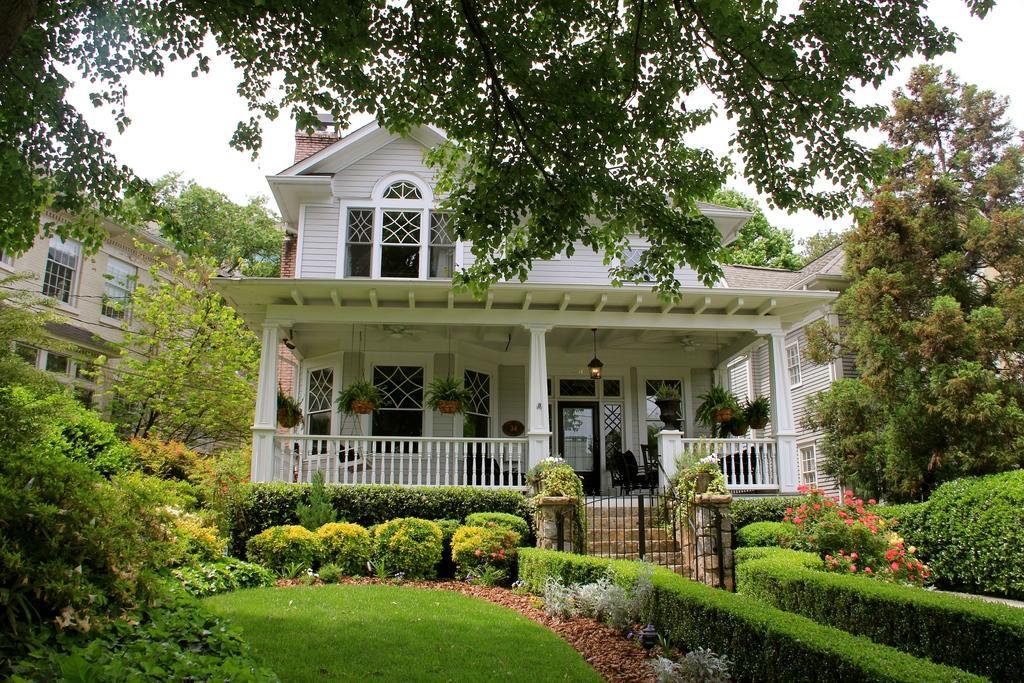Can you describe this image briefly? In the center of the image there are buildings. At the bottom we can see hedges and bushes. There is a gate and stairs. In the background there are trees and sky. 